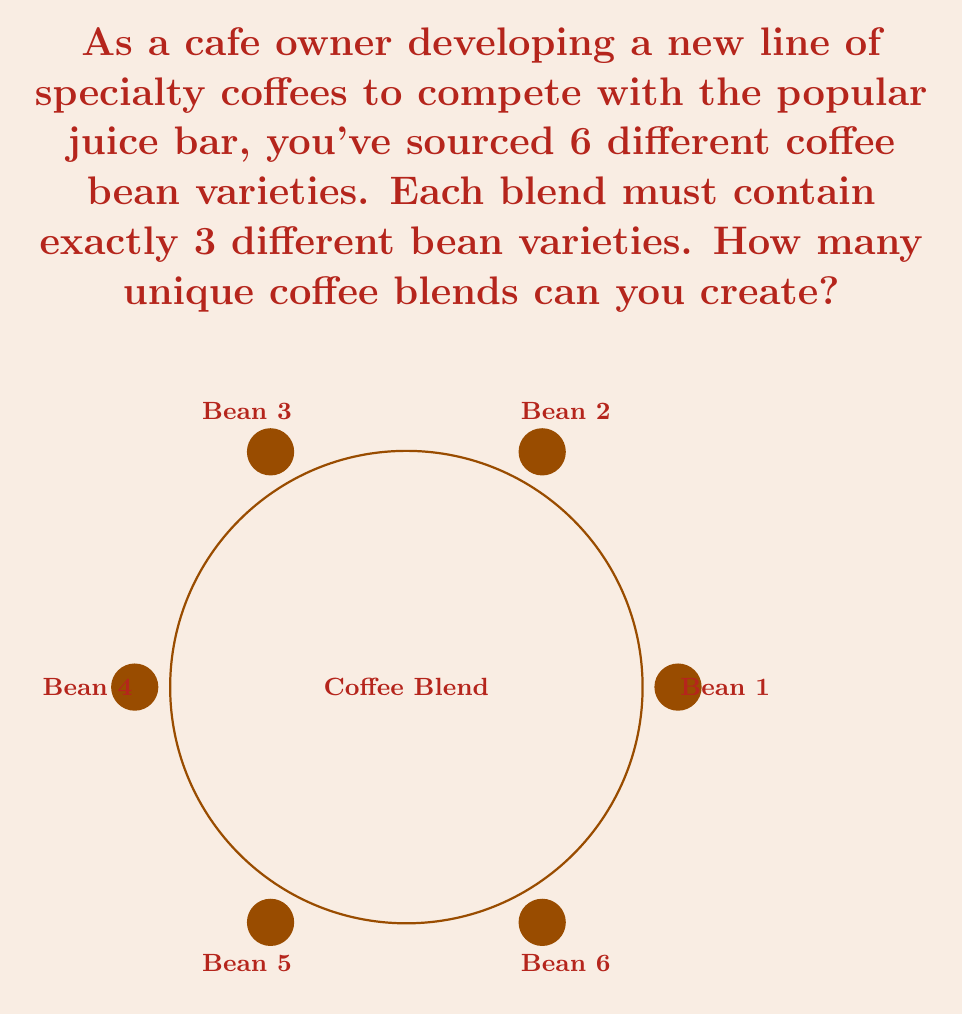Teach me how to tackle this problem. To solve this problem, we need to use the combination formula from combinatorics. We are selecting 3 bean varieties from a total of 6 varieties, where the order doesn't matter (since we're creating blends, not sequences).

The formula for combinations is:

$$ C(n,r) = \frac{n!}{r!(n-r)!} $$

Where:
$n$ is the total number of items to choose from (in this case, 6 bean varieties)
$r$ is the number of items being chosen (in this case, 3 for each blend)

Plugging in our values:

$$ C(6,3) = \frac{6!}{3!(6-3)!} = \frac{6!}{3!3!} $$

Now, let's calculate this step-by-step:

1) $6! = 6 \times 5 \times 4 \times 3 \times 2 \times 1 = 720$
2) $3! = 3 \times 2 \times 1 = 6$
3) $3! = 6$ (calculated again for the denominator)

Substituting these values:

$$ \frac{720}{6 \times 6} = \frac{720}{36} = 20 $$

Therefore, you can create 20 unique coffee blends using 3 bean varieties from your selection of 6 different beans.
Answer: 20 unique blends 